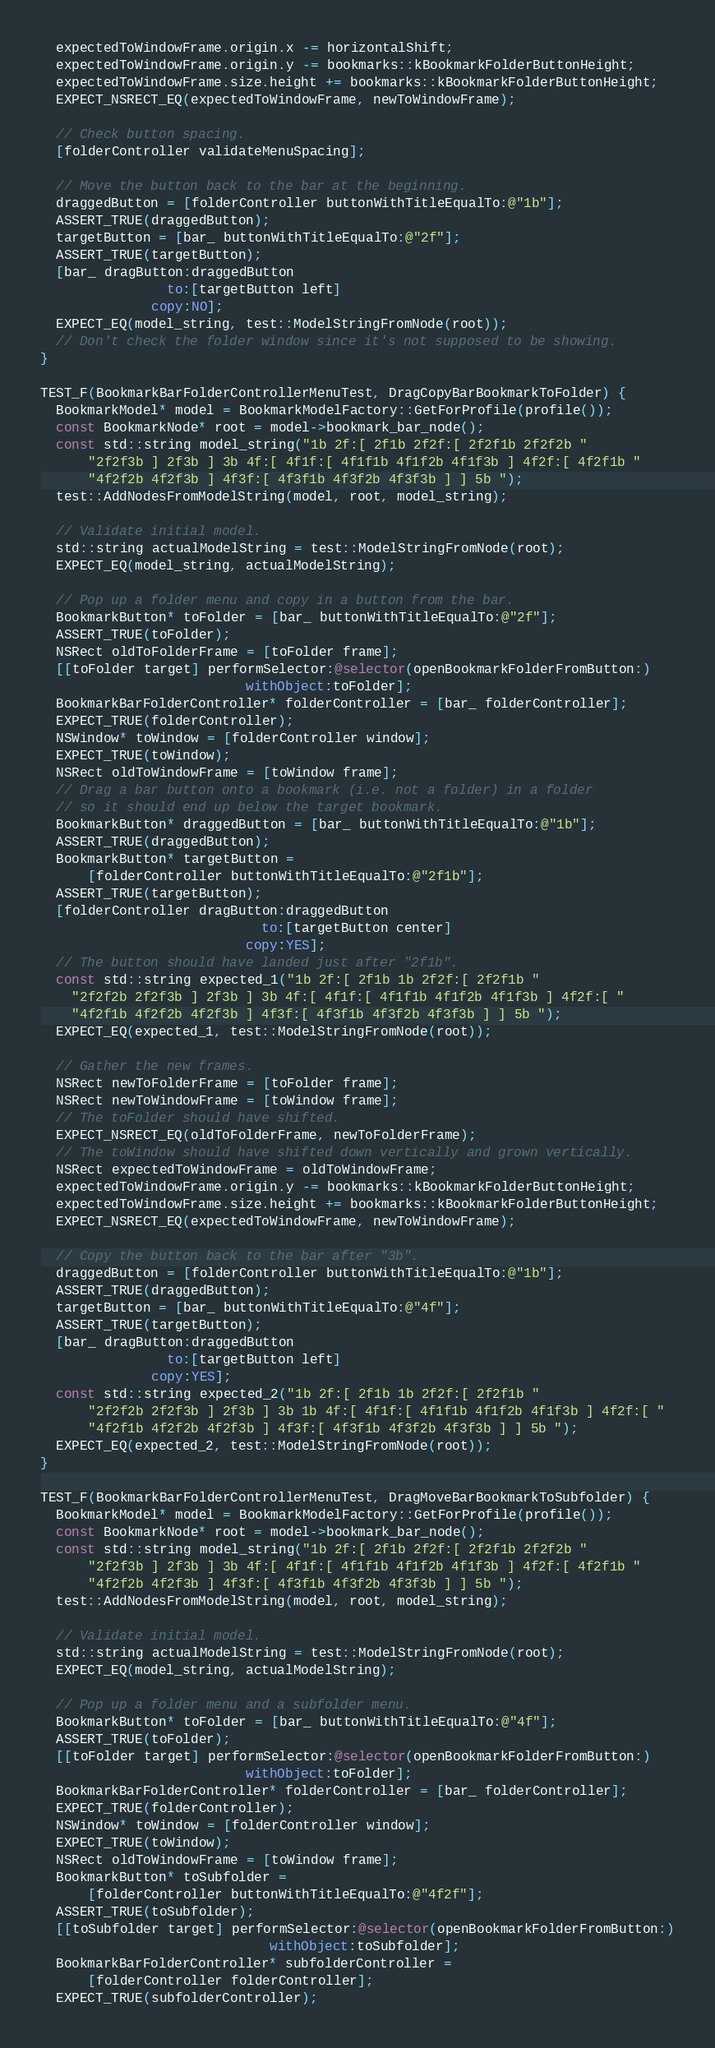<code> <loc_0><loc_0><loc_500><loc_500><_ObjectiveC_>  expectedToWindowFrame.origin.x -= horizontalShift;
  expectedToWindowFrame.origin.y -= bookmarks::kBookmarkFolderButtonHeight;
  expectedToWindowFrame.size.height += bookmarks::kBookmarkFolderButtonHeight;
  EXPECT_NSRECT_EQ(expectedToWindowFrame, newToWindowFrame);

  // Check button spacing.
  [folderController validateMenuSpacing];

  // Move the button back to the bar at the beginning.
  draggedButton = [folderController buttonWithTitleEqualTo:@"1b"];
  ASSERT_TRUE(draggedButton);
  targetButton = [bar_ buttonWithTitleEqualTo:@"2f"];
  ASSERT_TRUE(targetButton);
  [bar_ dragButton:draggedButton
                to:[targetButton left]
              copy:NO];
  EXPECT_EQ(model_string, test::ModelStringFromNode(root));
  // Don't check the folder window since it's not supposed to be showing.
}

TEST_F(BookmarkBarFolderControllerMenuTest, DragCopyBarBookmarkToFolder) {
  BookmarkModel* model = BookmarkModelFactory::GetForProfile(profile());
  const BookmarkNode* root = model->bookmark_bar_node();
  const std::string model_string("1b 2f:[ 2f1b 2f2f:[ 2f2f1b 2f2f2b "
      "2f2f3b ] 2f3b ] 3b 4f:[ 4f1f:[ 4f1f1b 4f1f2b 4f1f3b ] 4f2f:[ 4f2f1b "
      "4f2f2b 4f2f3b ] 4f3f:[ 4f3f1b 4f3f2b 4f3f3b ] ] 5b ");
  test::AddNodesFromModelString(model, root, model_string);

  // Validate initial model.
  std::string actualModelString = test::ModelStringFromNode(root);
  EXPECT_EQ(model_string, actualModelString);

  // Pop up a folder menu and copy in a button from the bar.
  BookmarkButton* toFolder = [bar_ buttonWithTitleEqualTo:@"2f"];
  ASSERT_TRUE(toFolder);
  NSRect oldToFolderFrame = [toFolder frame];
  [[toFolder target] performSelector:@selector(openBookmarkFolderFromButton:)
                          withObject:toFolder];
  BookmarkBarFolderController* folderController = [bar_ folderController];
  EXPECT_TRUE(folderController);
  NSWindow* toWindow = [folderController window];
  EXPECT_TRUE(toWindow);
  NSRect oldToWindowFrame = [toWindow frame];
  // Drag a bar button onto a bookmark (i.e. not a folder) in a folder
  // so it should end up below the target bookmark.
  BookmarkButton* draggedButton = [bar_ buttonWithTitleEqualTo:@"1b"];
  ASSERT_TRUE(draggedButton);
  BookmarkButton* targetButton =
      [folderController buttonWithTitleEqualTo:@"2f1b"];
  ASSERT_TRUE(targetButton);
  [folderController dragButton:draggedButton
                            to:[targetButton center]
                          copy:YES];
  // The button should have landed just after "2f1b".
  const std::string expected_1("1b 2f:[ 2f1b 1b 2f2f:[ 2f2f1b "
    "2f2f2b 2f2f3b ] 2f3b ] 3b 4f:[ 4f1f:[ 4f1f1b 4f1f2b 4f1f3b ] 4f2f:[ "
    "4f2f1b 4f2f2b 4f2f3b ] 4f3f:[ 4f3f1b 4f3f2b 4f3f3b ] ] 5b ");
  EXPECT_EQ(expected_1, test::ModelStringFromNode(root));

  // Gather the new frames.
  NSRect newToFolderFrame = [toFolder frame];
  NSRect newToWindowFrame = [toWindow frame];
  // The toFolder should have shifted.
  EXPECT_NSRECT_EQ(oldToFolderFrame, newToFolderFrame);
  // The toWindow should have shifted down vertically and grown vertically.
  NSRect expectedToWindowFrame = oldToWindowFrame;
  expectedToWindowFrame.origin.y -= bookmarks::kBookmarkFolderButtonHeight;
  expectedToWindowFrame.size.height += bookmarks::kBookmarkFolderButtonHeight;
  EXPECT_NSRECT_EQ(expectedToWindowFrame, newToWindowFrame);

  // Copy the button back to the bar after "3b".
  draggedButton = [folderController buttonWithTitleEqualTo:@"1b"];
  ASSERT_TRUE(draggedButton);
  targetButton = [bar_ buttonWithTitleEqualTo:@"4f"];
  ASSERT_TRUE(targetButton);
  [bar_ dragButton:draggedButton
                to:[targetButton left]
              copy:YES];
  const std::string expected_2("1b 2f:[ 2f1b 1b 2f2f:[ 2f2f1b "
      "2f2f2b 2f2f3b ] 2f3b ] 3b 1b 4f:[ 4f1f:[ 4f1f1b 4f1f2b 4f1f3b ] 4f2f:[ "
      "4f2f1b 4f2f2b 4f2f3b ] 4f3f:[ 4f3f1b 4f3f2b 4f3f3b ] ] 5b ");
  EXPECT_EQ(expected_2, test::ModelStringFromNode(root));
}

TEST_F(BookmarkBarFolderControllerMenuTest, DragMoveBarBookmarkToSubfolder) {
  BookmarkModel* model = BookmarkModelFactory::GetForProfile(profile());
  const BookmarkNode* root = model->bookmark_bar_node();
  const std::string model_string("1b 2f:[ 2f1b 2f2f:[ 2f2f1b 2f2f2b "
      "2f2f3b ] 2f3b ] 3b 4f:[ 4f1f:[ 4f1f1b 4f1f2b 4f1f3b ] 4f2f:[ 4f2f1b "
      "4f2f2b 4f2f3b ] 4f3f:[ 4f3f1b 4f3f2b 4f3f3b ] ] 5b ");
  test::AddNodesFromModelString(model, root, model_string);

  // Validate initial model.
  std::string actualModelString = test::ModelStringFromNode(root);
  EXPECT_EQ(model_string, actualModelString);

  // Pop up a folder menu and a subfolder menu.
  BookmarkButton* toFolder = [bar_ buttonWithTitleEqualTo:@"4f"];
  ASSERT_TRUE(toFolder);
  [[toFolder target] performSelector:@selector(openBookmarkFolderFromButton:)
                          withObject:toFolder];
  BookmarkBarFolderController* folderController = [bar_ folderController];
  EXPECT_TRUE(folderController);
  NSWindow* toWindow = [folderController window];
  EXPECT_TRUE(toWindow);
  NSRect oldToWindowFrame = [toWindow frame];
  BookmarkButton* toSubfolder =
      [folderController buttonWithTitleEqualTo:@"4f2f"];
  ASSERT_TRUE(toSubfolder);
  [[toSubfolder target] performSelector:@selector(openBookmarkFolderFromButton:)
                             withObject:toSubfolder];
  BookmarkBarFolderController* subfolderController =
      [folderController folderController];
  EXPECT_TRUE(subfolderController);</code> 